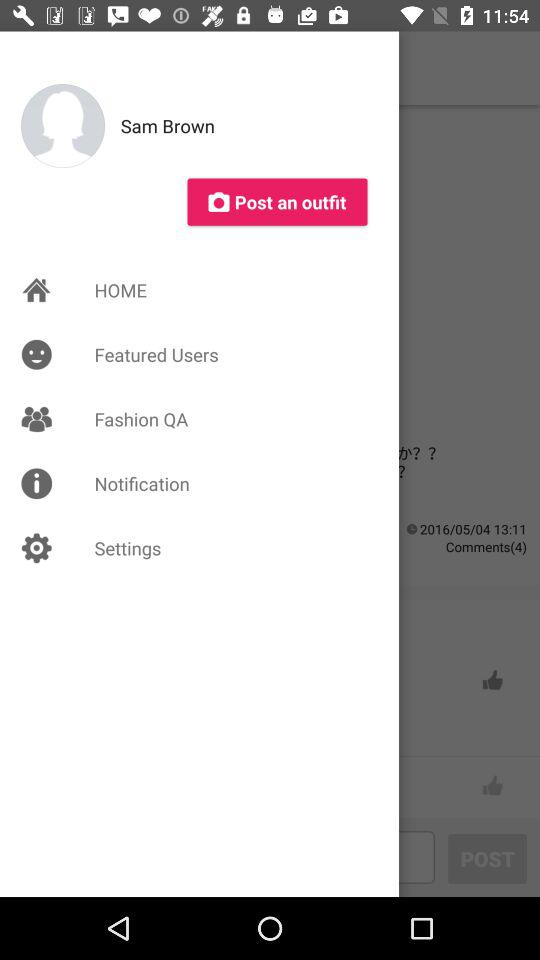What is the user name? The user name is Sam Brown. 